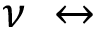Convert formula to latex. <formula><loc_0><loc_0><loc_500><loc_500>\nu \leftrightarrow</formula> 